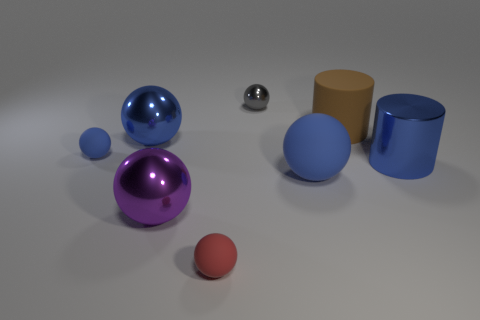How many blue spheres must be subtracted to get 1 blue spheres? 2 Subtract all purple blocks. How many blue spheres are left? 3 Subtract all large blue spheres. How many spheres are left? 4 Subtract all gray balls. How many balls are left? 5 Subtract 1 balls. How many balls are left? 5 Subtract all brown balls. Subtract all purple cubes. How many balls are left? 6 Add 1 big blue shiny cylinders. How many objects exist? 9 Subtract all cylinders. How many objects are left? 6 Subtract 0 red cylinders. How many objects are left? 8 Subtract all blue metal objects. Subtract all red things. How many objects are left? 5 